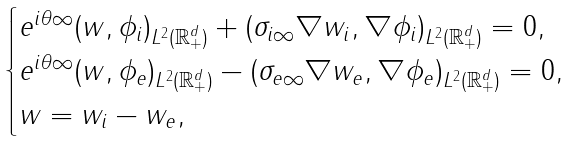<formula> <loc_0><loc_0><loc_500><loc_500>\begin{cases} e ^ { i \theta \infty } ( w , \phi _ { i } ) _ { L ^ { 2 } ( \mathbb { R } _ { + } ^ { d } ) } + ( \sigma _ { i \infty } \nabla w _ { i } , \nabla \phi _ { i } ) _ { L ^ { 2 } ( \mathbb { R } _ { + } ^ { d } ) } = 0 , \\ e ^ { i \theta \infty } ( w , \phi _ { e } ) _ { L ^ { 2 } ( \mathbb { R } _ { + } ^ { d } ) } - ( \sigma _ { e \infty } \nabla w _ { e } , \nabla \phi _ { e } ) _ { L ^ { 2 } ( \mathbb { R } _ { + } ^ { d } ) } = 0 , \\ w = w _ { i } - w _ { e } , \end{cases}</formula> 